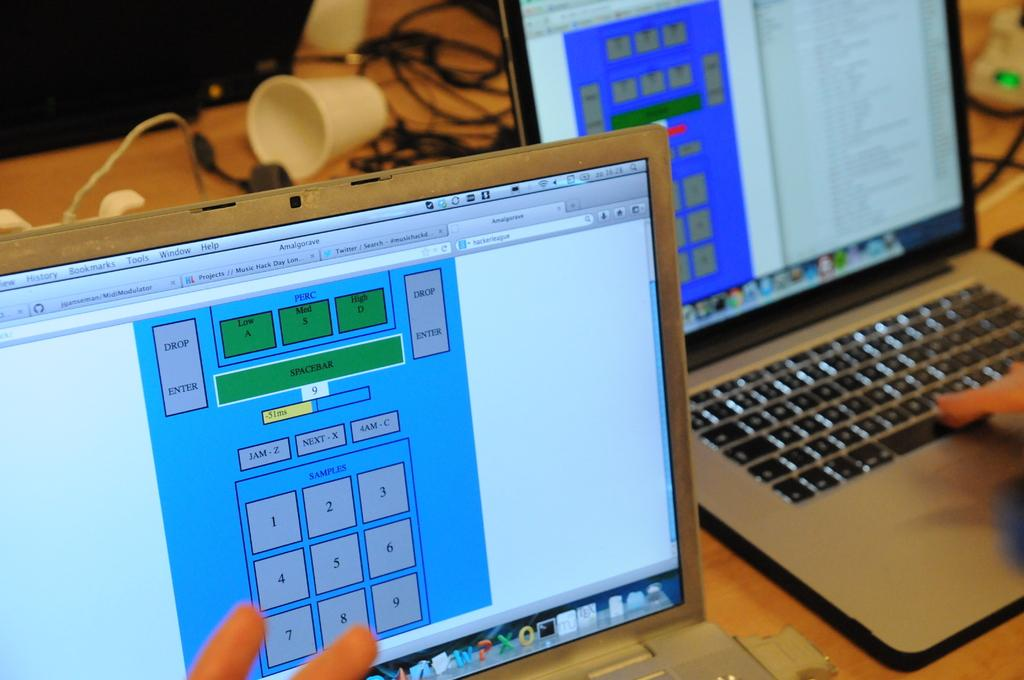<image>
Offer a succinct explanation of the picture presented. Two computer screens shown, the left screen has a top grey button saying drop enter. 